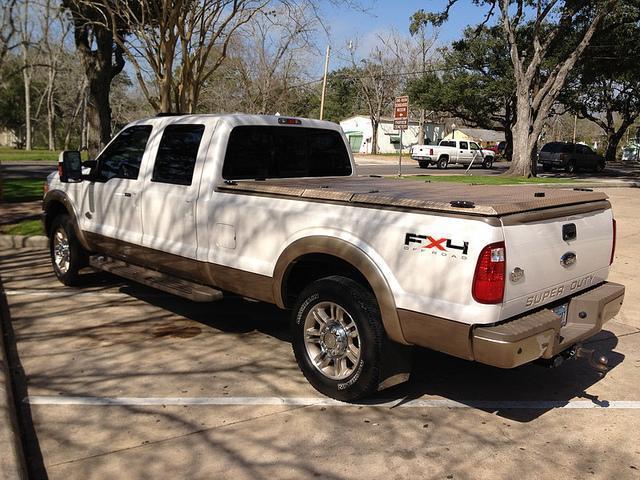How many vehicles in picture are white?
Give a very brief answer. 2. 